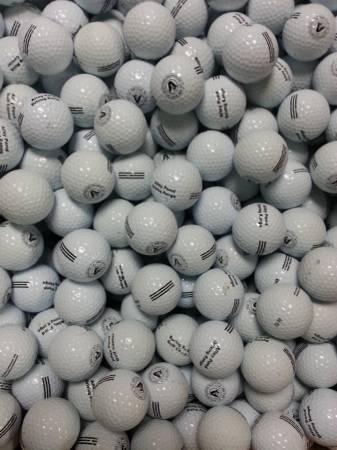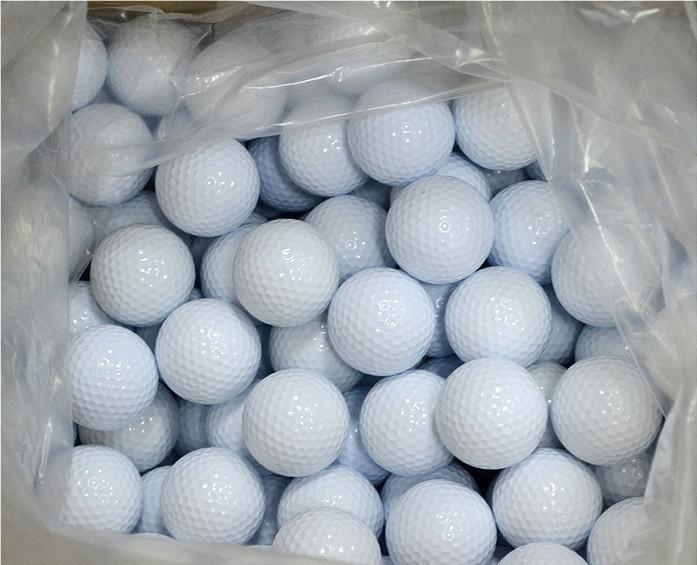The first image is the image on the left, the second image is the image on the right. Examine the images to the left and right. Is the description "None of the balls are in shadow in one of the images." accurate? Answer yes or no. Yes. 